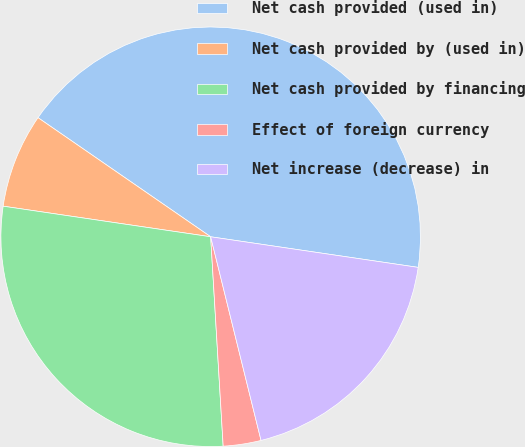Convert chart to OTSL. <chart><loc_0><loc_0><loc_500><loc_500><pie_chart><fcel>Net cash provided (used in)<fcel>Net cash provided by (used in)<fcel>Net cash provided by financing<fcel>Effect of foreign currency<fcel>Net increase (decrease) in<nl><fcel>42.72%<fcel>7.28%<fcel>28.28%<fcel>2.91%<fcel>18.81%<nl></chart> 